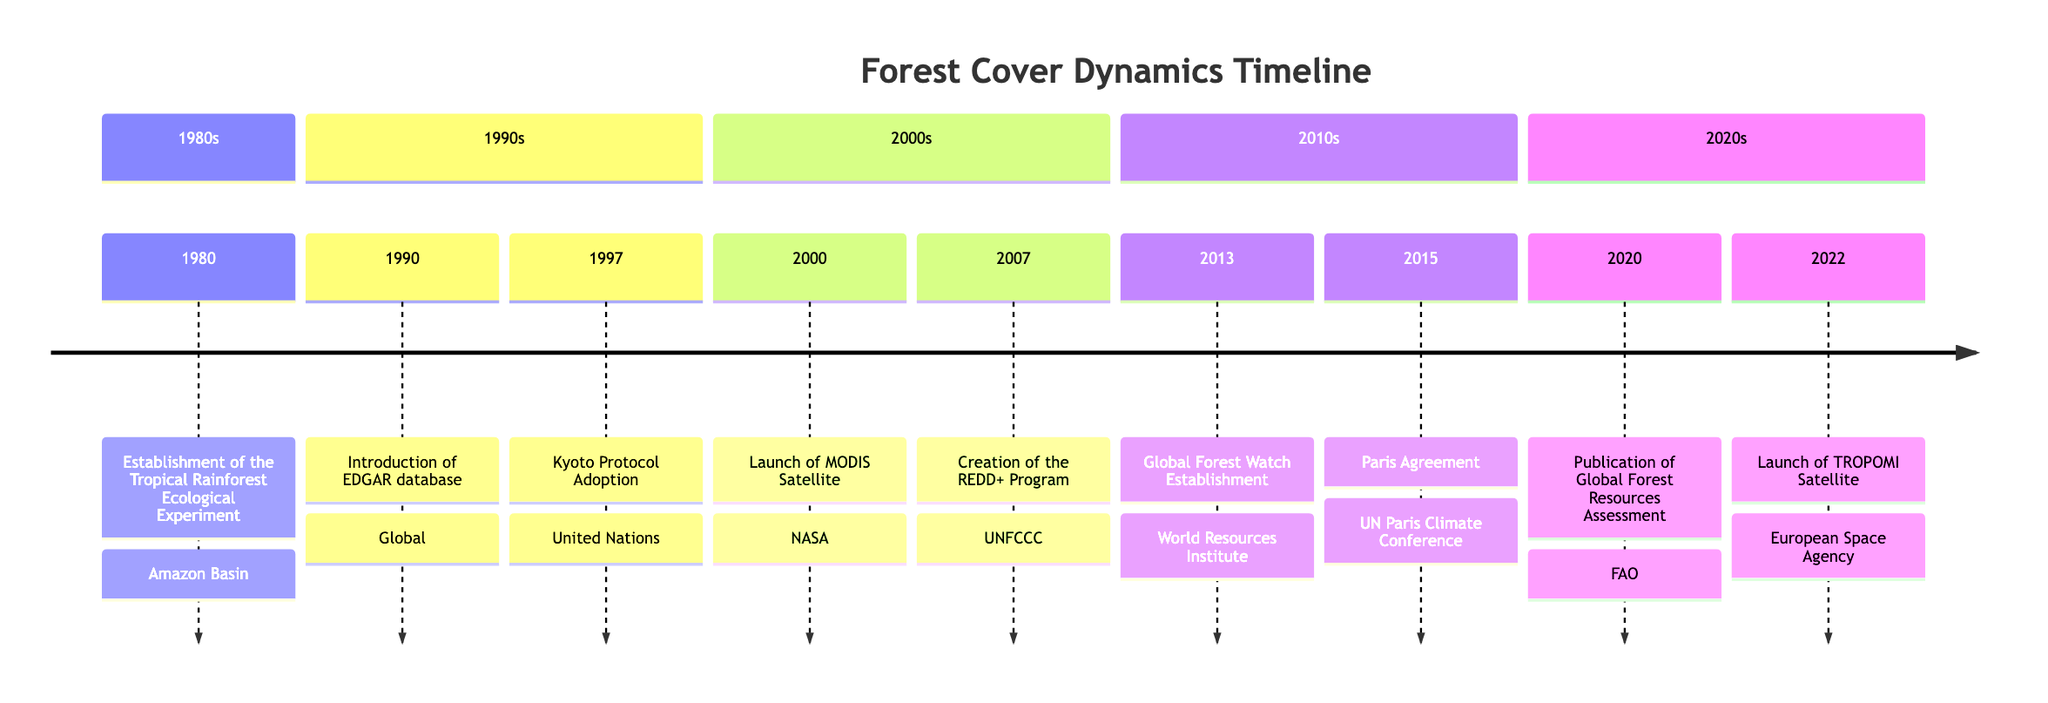What event took place in 1980? According to the timeline, in 1980, the establishment of the Tropical Rainforest Ecological Experiment occurred in the Amazon Basin.
Answer: Establishment of the Tropical Rainforest Ecological Experiment How many events are listed in the 1990s? The timeline indicates that there are three events listed for the 1990s: the Introduction of the EDGAR database in 1990 and the Kyoto Protocol Adoption in 1997. This counts as two distinct events.
Answer: 2 What organization launched the MODIS Satellite? The diagram specifies that NASA launched the MODIS Satellite in the year 2000, as listed in the section for that decade.
Answer: NASA What significant agreement was made in 2015? The timeline shows that the Paris Agreement was adopted in 2015 during the United Nations Paris Climate Conference, emphasizing sustainable forest management.
Answer: Paris Agreement Which two events focus on monitoring forest change using satellite technology? Observing the timeline, the events include the Launch of the MODIS Satellite in 2000 and the Launch of the TROPOMI Satellite in 2022. Both events highlight advancements in satellite technology for monitoring forests.
Answer: Launch of MODIS Satellite, Launch of TROPOMI Satellite What was the main focus of the REDD+ Program introduced in 2007? The details provided in the timeline clarify that the REDD+ Program, created in 2007, aimed to reduce emissions from deforestation and forest degradation while promoting sustainable forest management.
Answer: Reducing emissions from deforestation and forest degradation In which year did Global Forest Watch get established? Based on the timeline, the Global Forest Watch was established in 2013, as listed in the relevant section.
Answer: 2013 What aspect of forest cover did the FRA report published in 2020 address? The Global Forest Resources Assessment published in 2020 addressed trends in forest cover, deforestation, reforestation, and degradation over previous decades, as detailed in the timeline.
Answer: Trends in forest cover, deforestation, reforestation, and degradation Which two initiatives or programs were established prior to 2010? Reviewing the timeline, two initiatives established before 2010 are the Tropical Rainforest Ecological Experiment in 1980 and the introduction of the EDGAR database in 1990.
Answer: Tropical Rainforest Ecological Experiment, EDGAR database 